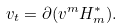<formula> <loc_0><loc_0><loc_500><loc_500>v _ { t } = \partial ( v ^ { m } H _ { m } ^ { * } ) .</formula> 